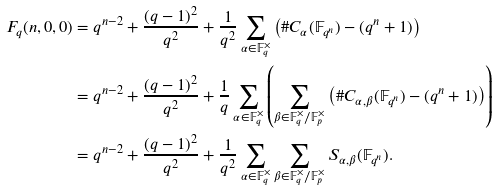<formula> <loc_0><loc_0><loc_500><loc_500>F _ { q } ( n , 0 , 0 ) & = q ^ { n - 2 } + \frac { ( q - 1 ) ^ { 2 } } { q ^ { 2 } } + \frac { 1 } { q ^ { 2 } } \sum _ { \alpha \in \mathbb { F } _ { q } ^ { \times } } \left ( \# C _ { \alpha } ( \mathbb { F } _ { q ^ { n } } ) - ( q ^ { n } + 1 ) \right ) \\ & = q ^ { n - 2 } + \frac { ( q - 1 ) ^ { 2 } } { q ^ { 2 } } + \frac { 1 } { q } \sum _ { \alpha \in \mathbb { F } _ { q } ^ { \times } } \left ( \sum _ { \beta \in \mathbb { F } _ { q } ^ { \times } / \mathbb { F } _ { p } ^ { \times } } \left ( \# C _ { \alpha , \beta } ( \mathbb { F } _ { q ^ { n } } ) - ( q ^ { n } + 1 ) \right ) \right ) \\ & = q ^ { n - 2 } + \frac { ( q - 1 ) ^ { 2 } } { q ^ { 2 } } + \frac { 1 } { q ^ { 2 } } \sum _ { \alpha \in \mathbb { F } _ { q } ^ { \times } } \sum _ { \beta \in \mathbb { F } _ { q } ^ { \times } / \mathbb { F } _ { p } ^ { \times } } S _ { \alpha , \beta } ( \mathbb { F } _ { q ^ { n } } ) .</formula> 